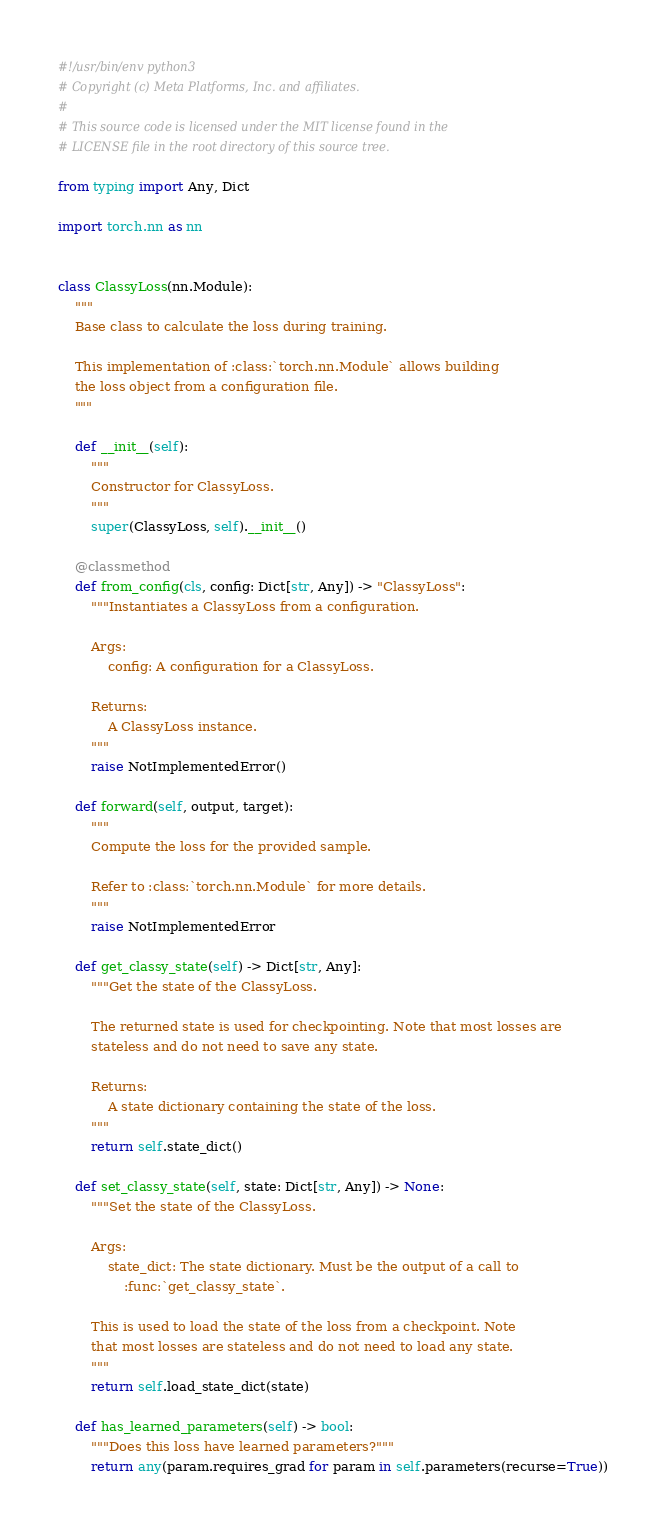<code> <loc_0><loc_0><loc_500><loc_500><_Python_>#!/usr/bin/env python3
# Copyright (c) Meta Platforms, Inc. and affiliates.
#
# This source code is licensed under the MIT license found in the
# LICENSE file in the root directory of this source tree.

from typing import Any, Dict

import torch.nn as nn


class ClassyLoss(nn.Module):
    """
    Base class to calculate the loss during training.

    This implementation of :class:`torch.nn.Module` allows building
    the loss object from a configuration file.
    """

    def __init__(self):
        """
        Constructor for ClassyLoss.
        """
        super(ClassyLoss, self).__init__()

    @classmethod
    def from_config(cls, config: Dict[str, Any]) -> "ClassyLoss":
        """Instantiates a ClassyLoss from a configuration.

        Args:
            config: A configuration for a ClassyLoss.

        Returns:
            A ClassyLoss instance.
        """
        raise NotImplementedError()

    def forward(self, output, target):
        """
        Compute the loss for the provided sample.

        Refer to :class:`torch.nn.Module` for more details.
        """
        raise NotImplementedError

    def get_classy_state(self) -> Dict[str, Any]:
        """Get the state of the ClassyLoss.

        The returned state is used for checkpointing. Note that most losses are
        stateless and do not need to save any state.

        Returns:
            A state dictionary containing the state of the loss.
        """
        return self.state_dict()

    def set_classy_state(self, state: Dict[str, Any]) -> None:
        """Set the state of the ClassyLoss.

        Args:
            state_dict: The state dictionary. Must be the output of a call to
                :func:`get_classy_state`.

        This is used to load the state of the loss from a checkpoint. Note
        that most losses are stateless and do not need to load any state.
        """
        return self.load_state_dict(state)

    def has_learned_parameters(self) -> bool:
        """Does this loss have learned parameters?"""
        return any(param.requires_grad for param in self.parameters(recurse=True))
</code> 